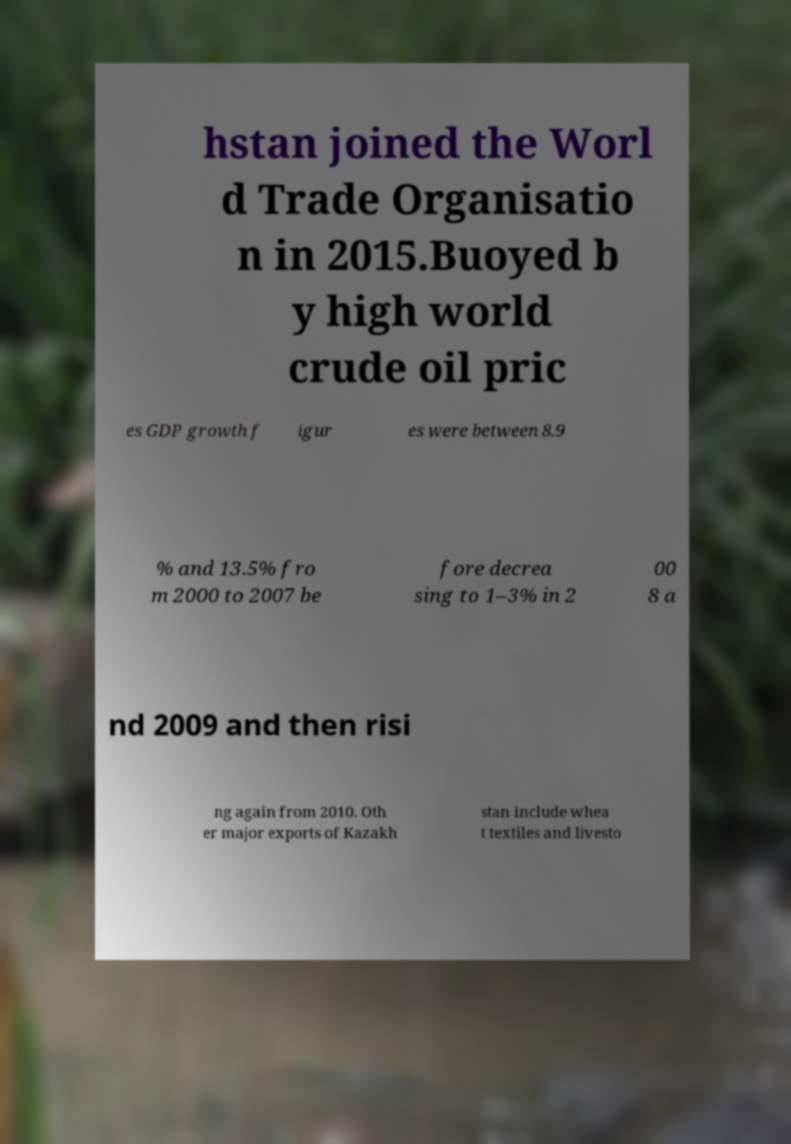I need the written content from this picture converted into text. Can you do that? hstan joined the Worl d Trade Organisatio n in 2015.Buoyed b y high world crude oil pric es GDP growth f igur es were between 8.9 % and 13.5% fro m 2000 to 2007 be fore decrea sing to 1–3% in 2 00 8 a nd 2009 and then risi ng again from 2010. Oth er major exports of Kazakh stan include whea t textiles and livesto 